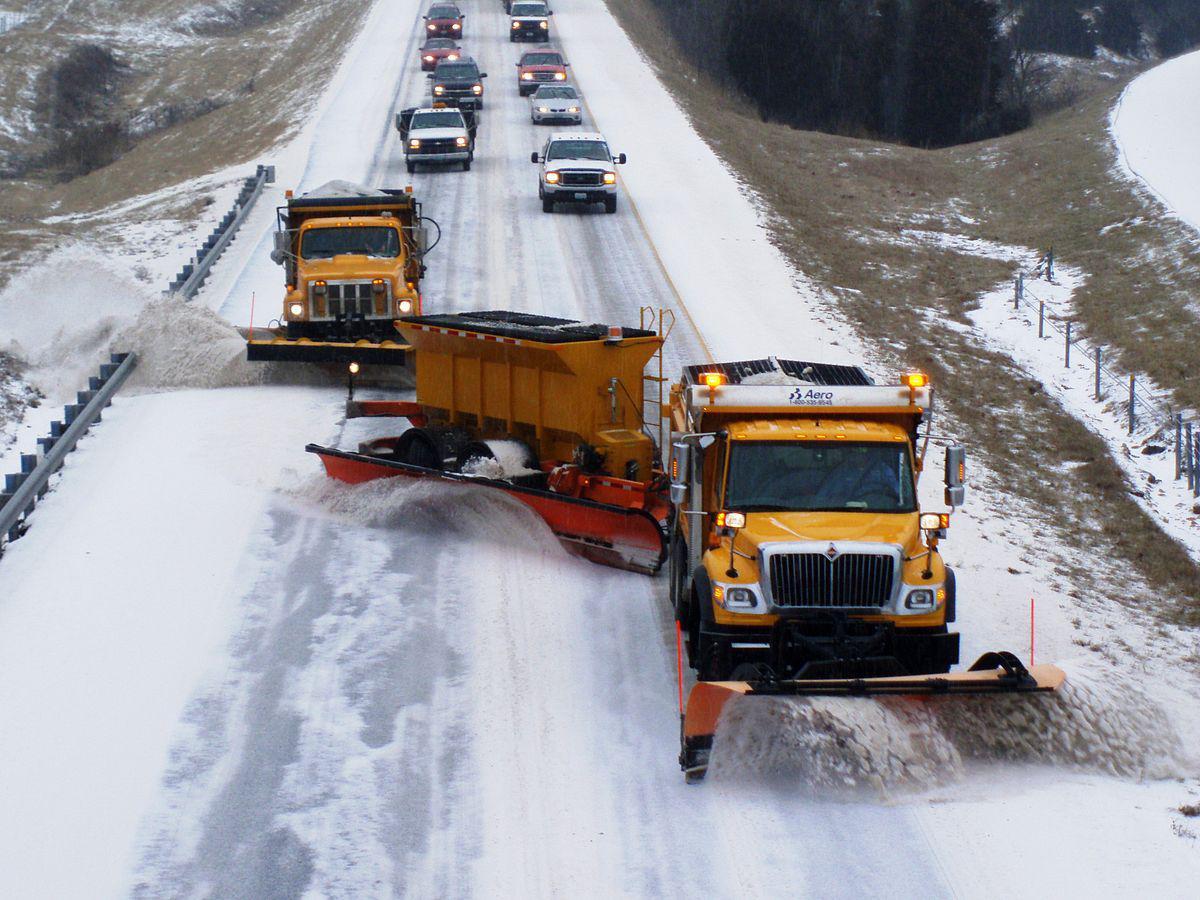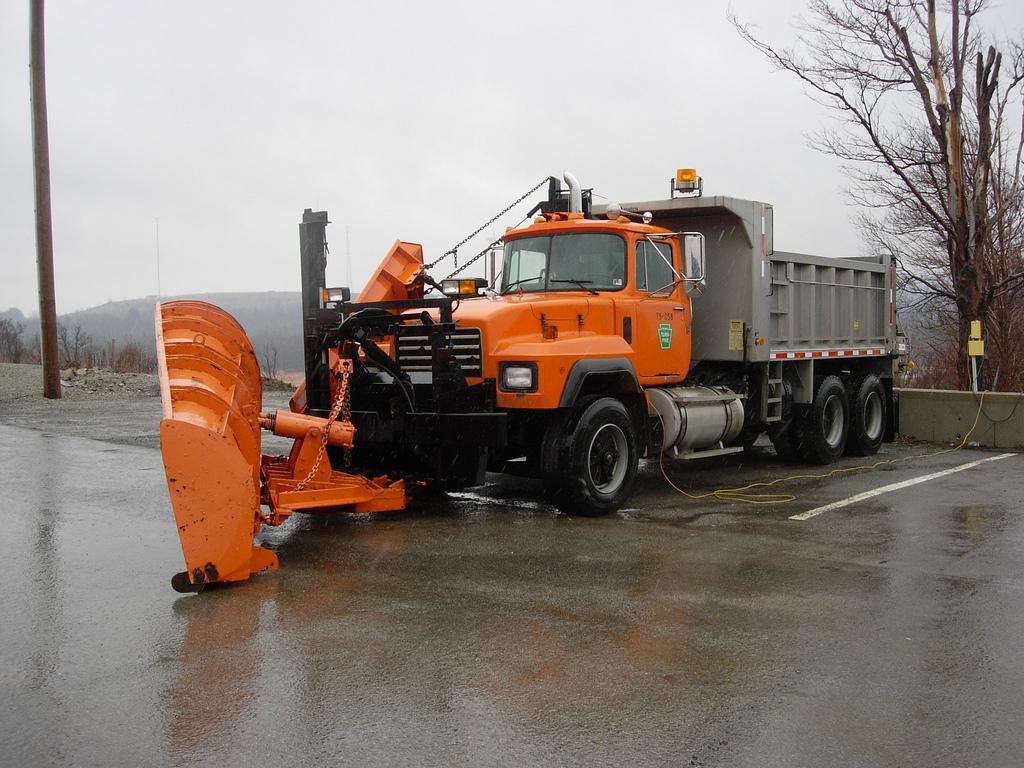The first image is the image on the left, the second image is the image on the right. Given the left and right images, does the statement "One image shows just one truck with a solid orange plow." hold true? Answer yes or no. Yes. 